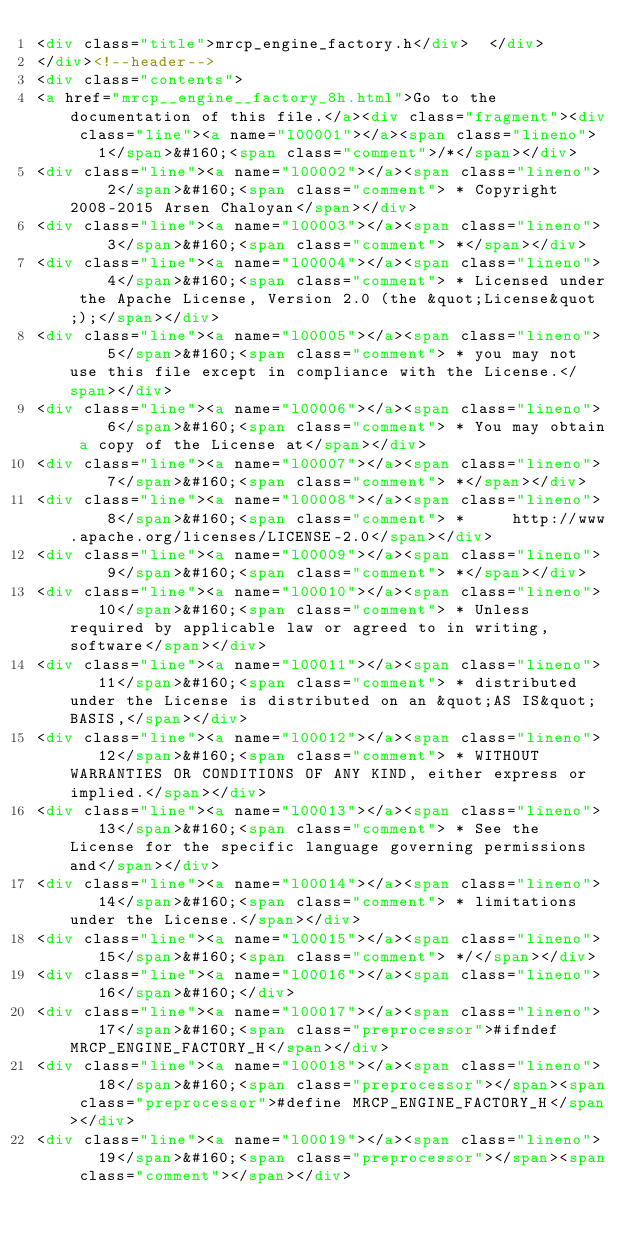<code> <loc_0><loc_0><loc_500><loc_500><_HTML_><div class="title">mrcp_engine_factory.h</div>  </div>
</div><!--header-->
<div class="contents">
<a href="mrcp__engine__factory_8h.html">Go to the documentation of this file.</a><div class="fragment"><div class="line"><a name="l00001"></a><span class="lineno">    1</span>&#160;<span class="comment">/*</span></div>
<div class="line"><a name="l00002"></a><span class="lineno">    2</span>&#160;<span class="comment"> * Copyright 2008-2015 Arsen Chaloyan</span></div>
<div class="line"><a name="l00003"></a><span class="lineno">    3</span>&#160;<span class="comment"> *</span></div>
<div class="line"><a name="l00004"></a><span class="lineno">    4</span>&#160;<span class="comment"> * Licensed under the Apache License, Version 2.0 (the &quot;License&quot;);</span></div>
<div class="line"><a name="l00005"></a><span class="lineno">    5</span>&#160;<span class="comment"> * you may not use this file except in compliance with the License.</span></div>
<div class="line"><a name="l00006"></a><span class="lineno">    6</span>&#160;<span class="comment"> * You may obtain a copy of the License at</span></div>
<div class="line"><a name="l00007"></a><span class="lineno">    7</span>&#160;<span class="comment"> *</span></div>
<div class="line"><a name="l00008"></a><span class="lineno">    8</span>&#160;<span class="comment"> *     http://www.apache.org/licenses/LICENSE-2.0</span></div>
<div class="line"><a name="l00009"></a><span class="lineno">    9</span>&#160;<span class="comment"> *</span></div>
<div class="line"><a name="l00010"></a><span class="lineno">   10</span>&#160;<span class="comment"> * Unless required by applicable law or agreed to in writing, software</span></div>
<div class="line"><a name="l00011"></a><span class="lineno">   11</span>&#160;<span class="comment"> * distributed under the License is distributed on an &quot;AS IS&quot; BASIS,</span></div>
<div class="line"><a name="l00012"></a><span class="lineno">   12</span>&#160;<span class="comment"> * WITHOUT WARRANTIES OR CONDITIONS OF ANY KIND, either express or implied.</span></div>
<div class="line"><a name="l00013"></a><span class="lineno">   13</span>&#160;<span class="comment"> * See the License for the specific language governing permissions and</span></div>
<div class="line"><a name="l00014"></a><span class="lineno">   14</span>&#160;<span class="comment"> * limitations under the License.</span></div>
<div class="line"><a name="l00015"></a><span class="lineno">   15</span>&#160;<span class="comment"> */</span></div>
<div class="line"><a name="l00016"></a><span class="lineno">   16</span>&#160;</div>
<div class="line"><a name="l00017"></a><span class="lineno">   17</span>&#160;<span class="preprocessor">#ifndef MRCP_ENGINE_FACTORY_H</span></div>
<div class="line"><a name="l00018"></a><span class="lineno">   18</span>&#160;<span class="preprocessor"></span><span class="preprocessor">#define MRCP_ENGINE_FACTORY_H</span></div>
<div class="line"><a name="l00019"></a><span class="lineno">   19</span>&#160;<span class="preprocessor"></span><span class="comment"></span></div></code> 